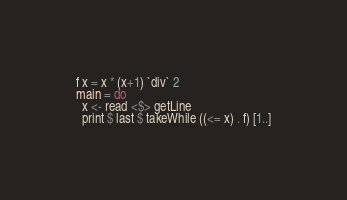<code> <loc_0><loc_0><loc_500><loc_500><_Haskell_>f x = x * (x+1) `div` 2
main = do
  x <- read <$> getLine
  print $ last $ takeWhile ((<= x) . f) [1..]</code> 